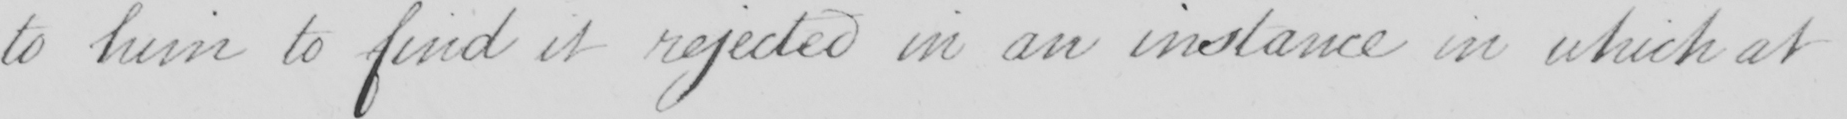Can you read and transcribe this handwriting? to him to find it rejected in an instance in which at 